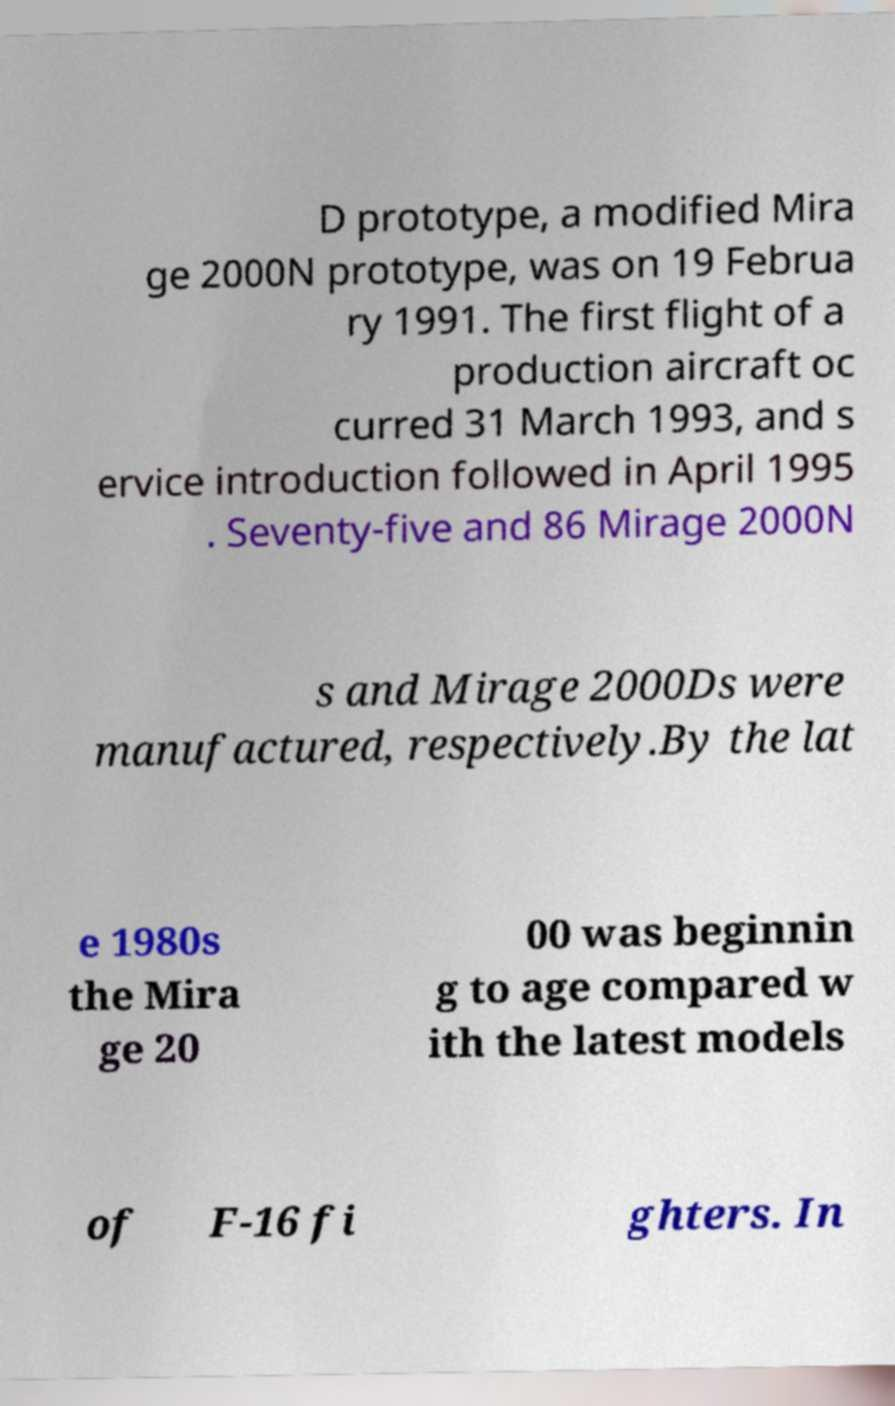Can you read and provide the text displayed in the image?This photo seems to have some interesting text. Can you extract and type it out for me? D prototype, a modified Mira ge 2000N prototype, was on 19 Februa ry 1991. The first flight of a production aircraft oc curred 31 March 1993, and s ervice introduction followed in April 1995 . Seventy-five and 86 Mirage 2000N s and Mirage 2000Ds were manufactured, respectively.By the lat e 1980s the Mira ge 20 00 was beginnin g to age compared w ith the latest models of F-16 fi ghters. In 